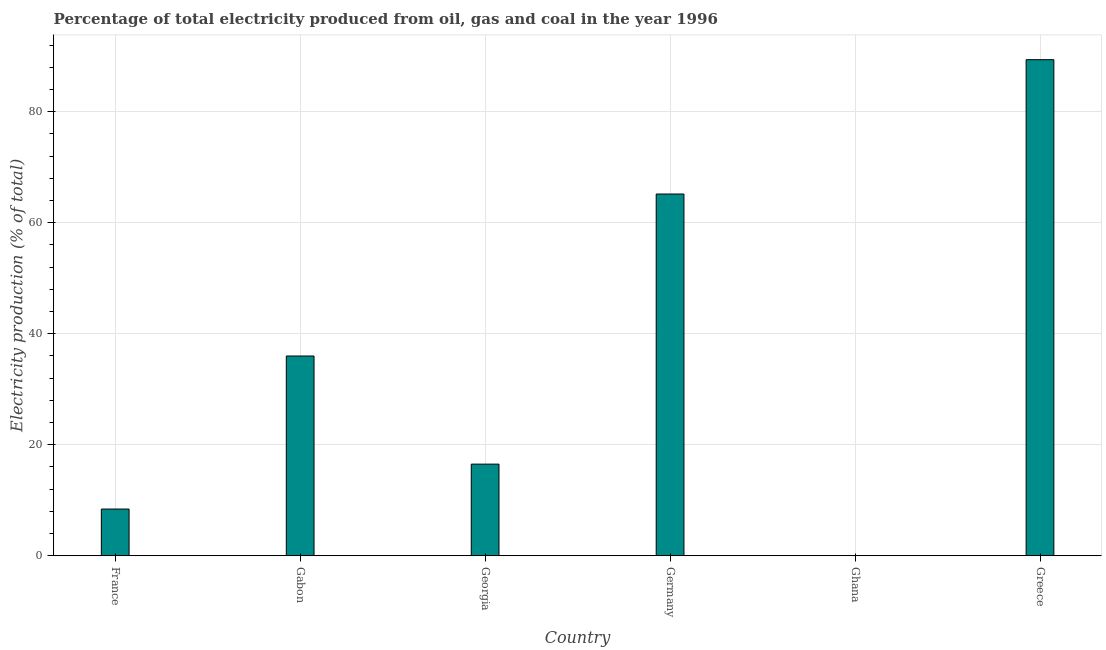Does the graph contain grids?
Your answer should be compact. Yes. What is the title of the graph?
Provide a succinct answer. Percentage of total electricity produced from oil, gas and coal in the year 1996. What is the label or title of the X-axis?
Offer a terse response. Country. What is the label or title of the Y-axis?
Provide a short and direct response. Electricity production (% of total). What is the electricity production in France?
Provide a short and direct response. 8.42. Across all countries, what is the maximum electricity production?
Your response must be concise. 89.39. Across all countries, what is the minimum electricity production?
Keep it short and to the point. 0.03. In which country was the electricity production maximum?
Ensure brevity in your answer.  Greece. In which country was the electricity production minimum?
Offer a very short reply. Ghana. What is the sum of the electricity production?
Give a very brief answer. 215.53. What is the difference between the electricity production in Georgia and Greece?
Keep it short and to the point. -72.87. What is the average electricity production per country?
Provide a succinct answer. 35.92. What is the median electricity production?
Offer a very short reply. 26.26. In how many countries, is the electricity production greater than 52 %?
Your answer should be compact. 2. What is the ratio of the electricity production in Georgia to that in Greece?
Make the answer very short. 0.18. Is the electricity production in Germany less than that in Greece?
Your answer should be compact. Yes. What is the difference between the highest and the second highest electricity production?
Offer a very short reply. 24.2. Is the sum of the electricity production in France and Ghana greater than the maximum electricity production across all countries?
Your answer should be compact. No. What is the difference between the highest and the lowest electricity production?
Offer a terse response. 89.36. How many countries are there in the graph?
Offer a very short reply. 6. What is the difference between two consecutive major ticks on the Y-axis?
Offer a very short reply. 20. What is the Electricity production (% of total) in France?
Ensure brevity in your answer.  8.42. What is the Electricity production (% of total) in Gabon?
Your answer should be very brief. 36. What is the Electricity production (% of total) of Georgia?
Provide a succinct answer. 16.52. What is the Electricity production (% of total) of Germany?
Keep it short and to the point. 65.18. What is the Electricity production (% of total) in Ghana?
Your response must be concise. 0.03. What is the Electricity production (% of total) of Greece?
Make the answer very short. 89.39. What is the difference between the Electricity production (% of total) in France and Gabon?
Offer a terse response. -27.58. What is the difference between the Electricity production (% of total) in France and Georgia?
Keep it short and to the point. -8.09. What is the difference between the Electricity production (% of total) in France and Germany?
Provide a succinct answer. -56.76. What is the difference between the Electricity production (% of total) in France and Ghana?
Provide a short and direct response. 8.39. What is the difference between the Electricity production (% of total) in France and Greece?
Give a very brief answer. -80.97. What is the difference between the Electricity production (% of total) in Gabon and Georgia?
Provide a succinct answer. 19.48. What is the difference between the Electricity production (% of total) in Gabon and Germany?
Your response must be concise. -29.19. What is the difference between the Electricity production (% of total) in Gabon and Ghana?
Keep it short and to the point. 35.97. What is the difference between the Electricity production (% of total) in Gabon and Greece?
Provide a short and direct response. -53.39. What is the difference between the Electricity production (% of total) in Georgia and Germany?
Give a very brief answer. -48.67. What is the difference between the Electricity production (% of total) in Georgia and Ghana?
Your response must be concise. 16.49. What is the difference between the Electricity production (% of total) in Georgia and Greece?
Make the answer very short. -72.87. What is the difference between the Electricity production (% of total) in Germany and Ghana?
Make the answer very short. 65.15. What is the difference between the Electricity production (% of total) in Germany and Greece?
Make the answer very short. -24.2. What is the difference between the Electricity production (% of total) in Ghana and Greece?
Your answer should be compact. -89.36. What is the ratio of the Electricity production (% of total) in France to that in Gabon?
Give a very brief answer. 0.23. What is the ratio of the Electricity production (% of total) in France to that in Georgia?
Ensure brevity in your answer.  0.51. What is the ratio of the Electricity production (% of total) in France to that in Germany?
Provide a succinct answer. 0.13. What is the ratio of the Electricity production (% of total) in France to that in Ghana?
Your response must be concise. 279.04. What is the ratio of the Electricity production (% of total) in France to that in Greece?
Offer a terse response. 0.09. What is the ratio of the Electricity production (% of total) in Gabon to that in Georgia?
Give a very brief answer. 2.18. What is the ratio of the Electricity production (% of total) in Gabon to that in Germany?
Give a very brief answer. 0.55. What is the ratio of the Electricity production (% of total) in Gabon to that in Ghana?
Ensure brevity in your answer.  1192.75. What is the ratio of the Electricity production (% of total) in Gabon to that in Greece?
Make the answer very short. 0.4. What is the ratio of the Electricity production (% of total) in Georgia to that in Germany?
Your answer should be compact. 0.25. What is the ratio of the Electricity production (% of total) in Georgia to that in Ghana?
Your answer should be very brief. 547.25. What is the ratio of the Electricity production (% of total) in Georgia to that in Greece?
Keep it short and to the point. 0.18. What is the ratio of the Electricity production (% of total) in Germany to that in Ghana?
Provide a succinct answer. 2159.85. What is the ratio of the Electricity production (% of total) in Germany to that in Greece?
Make the answer very short. 0.73. What is the ratio of the Electricity production (% of total) in Ghana to that in Greece?
Keep it short and to the point. 0. 